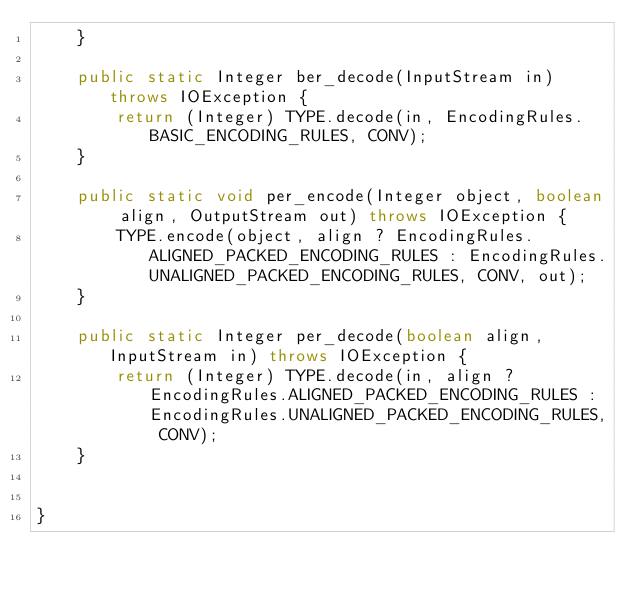<code> <loc_0><loc_0><loc_500><loc_500><_Java_>    }

    public static Integer ber_decode(InputStream in) throws IOException {
        return (Integer) TYPE.decode(in, EncodingRules.BASIC_ENCODING_RULES, CONV);
    }

    public static void per_encode(Integer object, boolean align, OutputStream out) throws IOException {
        TYPE.encode(object, align ? EncodingRules.ALIGNED_PACKED_ENCODING_RULES : EncodingRules.UNALIGNED_PACKED_ENCODING_RULES, CONV, out);
    }

    public static Integer per_decode(boolean align, InputStream in) throws IOException {
        return (Integer) TYPE.decode(in, align ? EncodingRules.ALIGNED_PACKED_ENCODING_RULES : EncodingRules.UNALIGNED_PACKED_ENCODING_RULES, CONV);
    }


}
</code> 